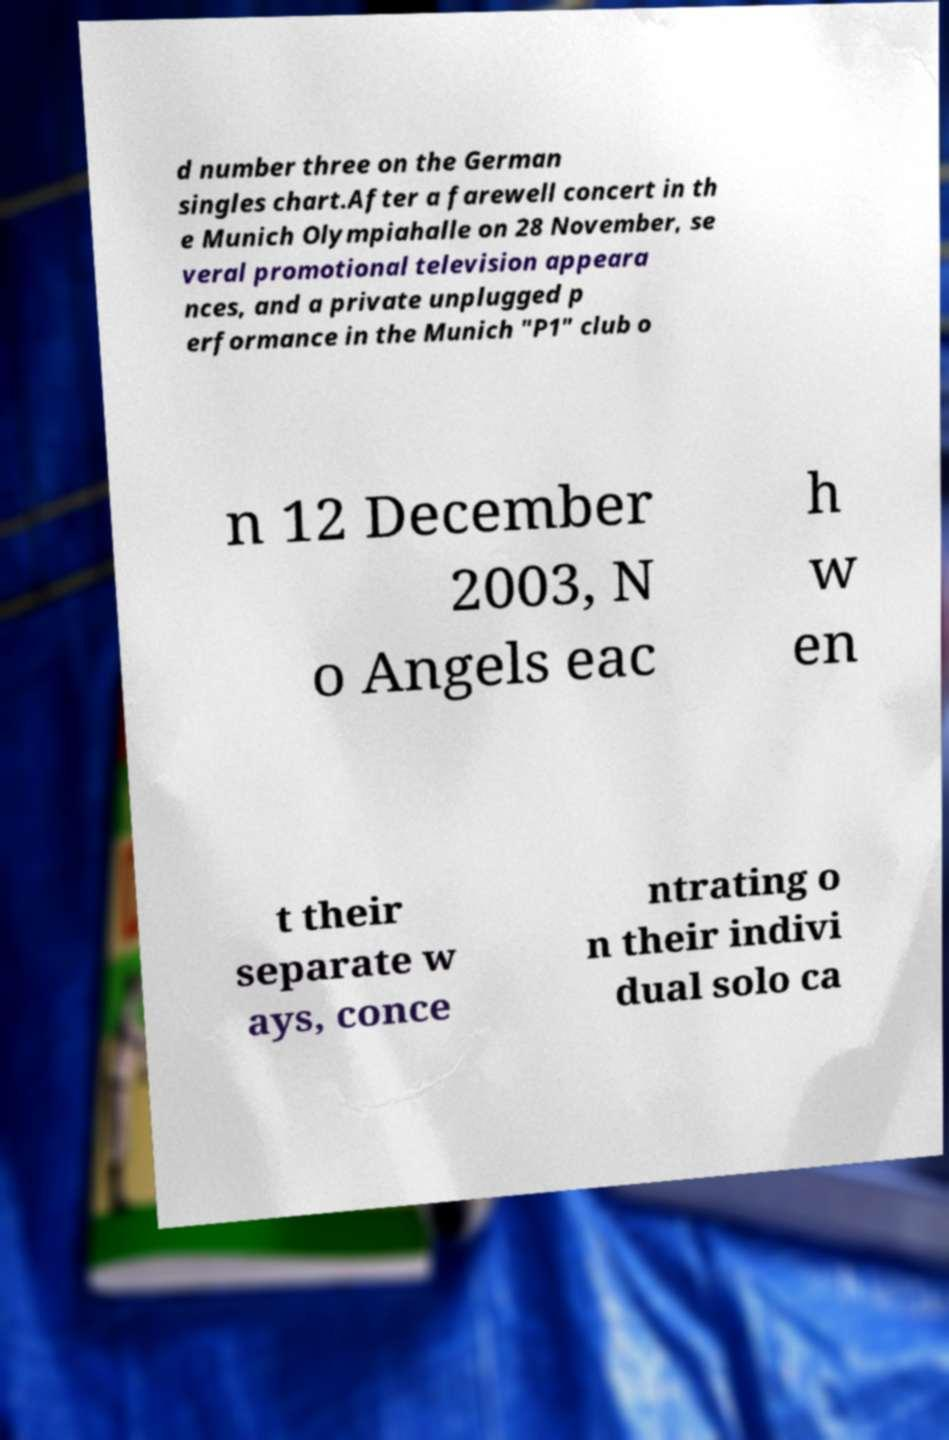Could you assist in decoding the text presented in this image and type it out clearly? d number three on the German singles chart.After a farewell concert in th e Munich Olympiahalle on 28 November, se veral promotional television appeara nces, and a private unplugged p erformance in the Munich "P1" club o n 12 December 2003, N o Angels eac h w en t their separate w ays, conce ntrating o n their indivi dual solo ca 